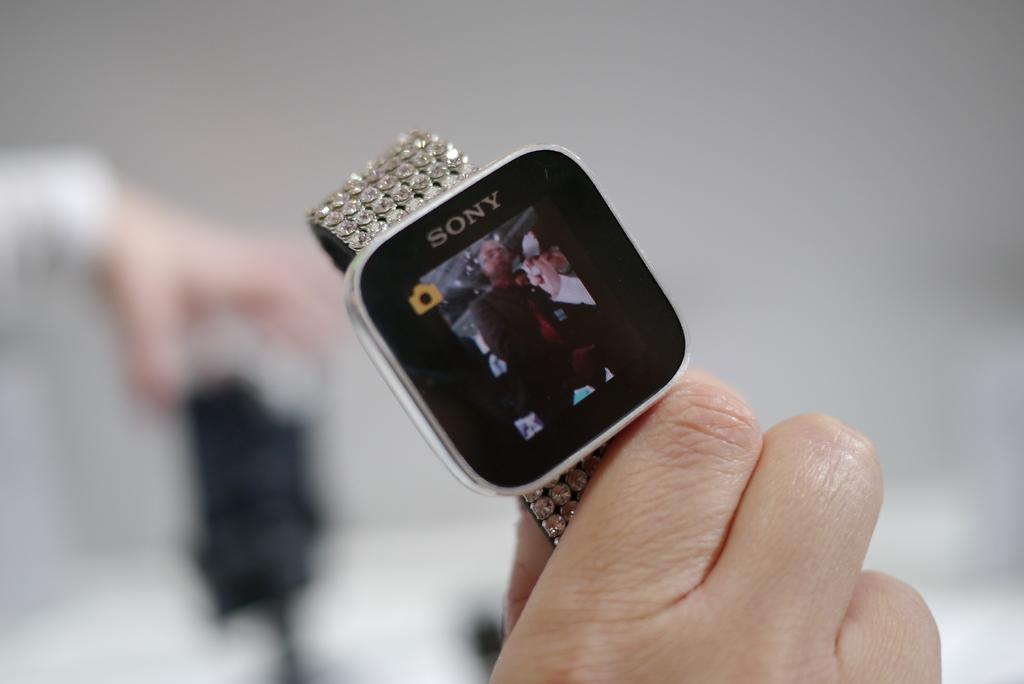<image>
Share a concise interpretation of the image provided. A Sony smart watch has a tiny camera icon in the corner. 